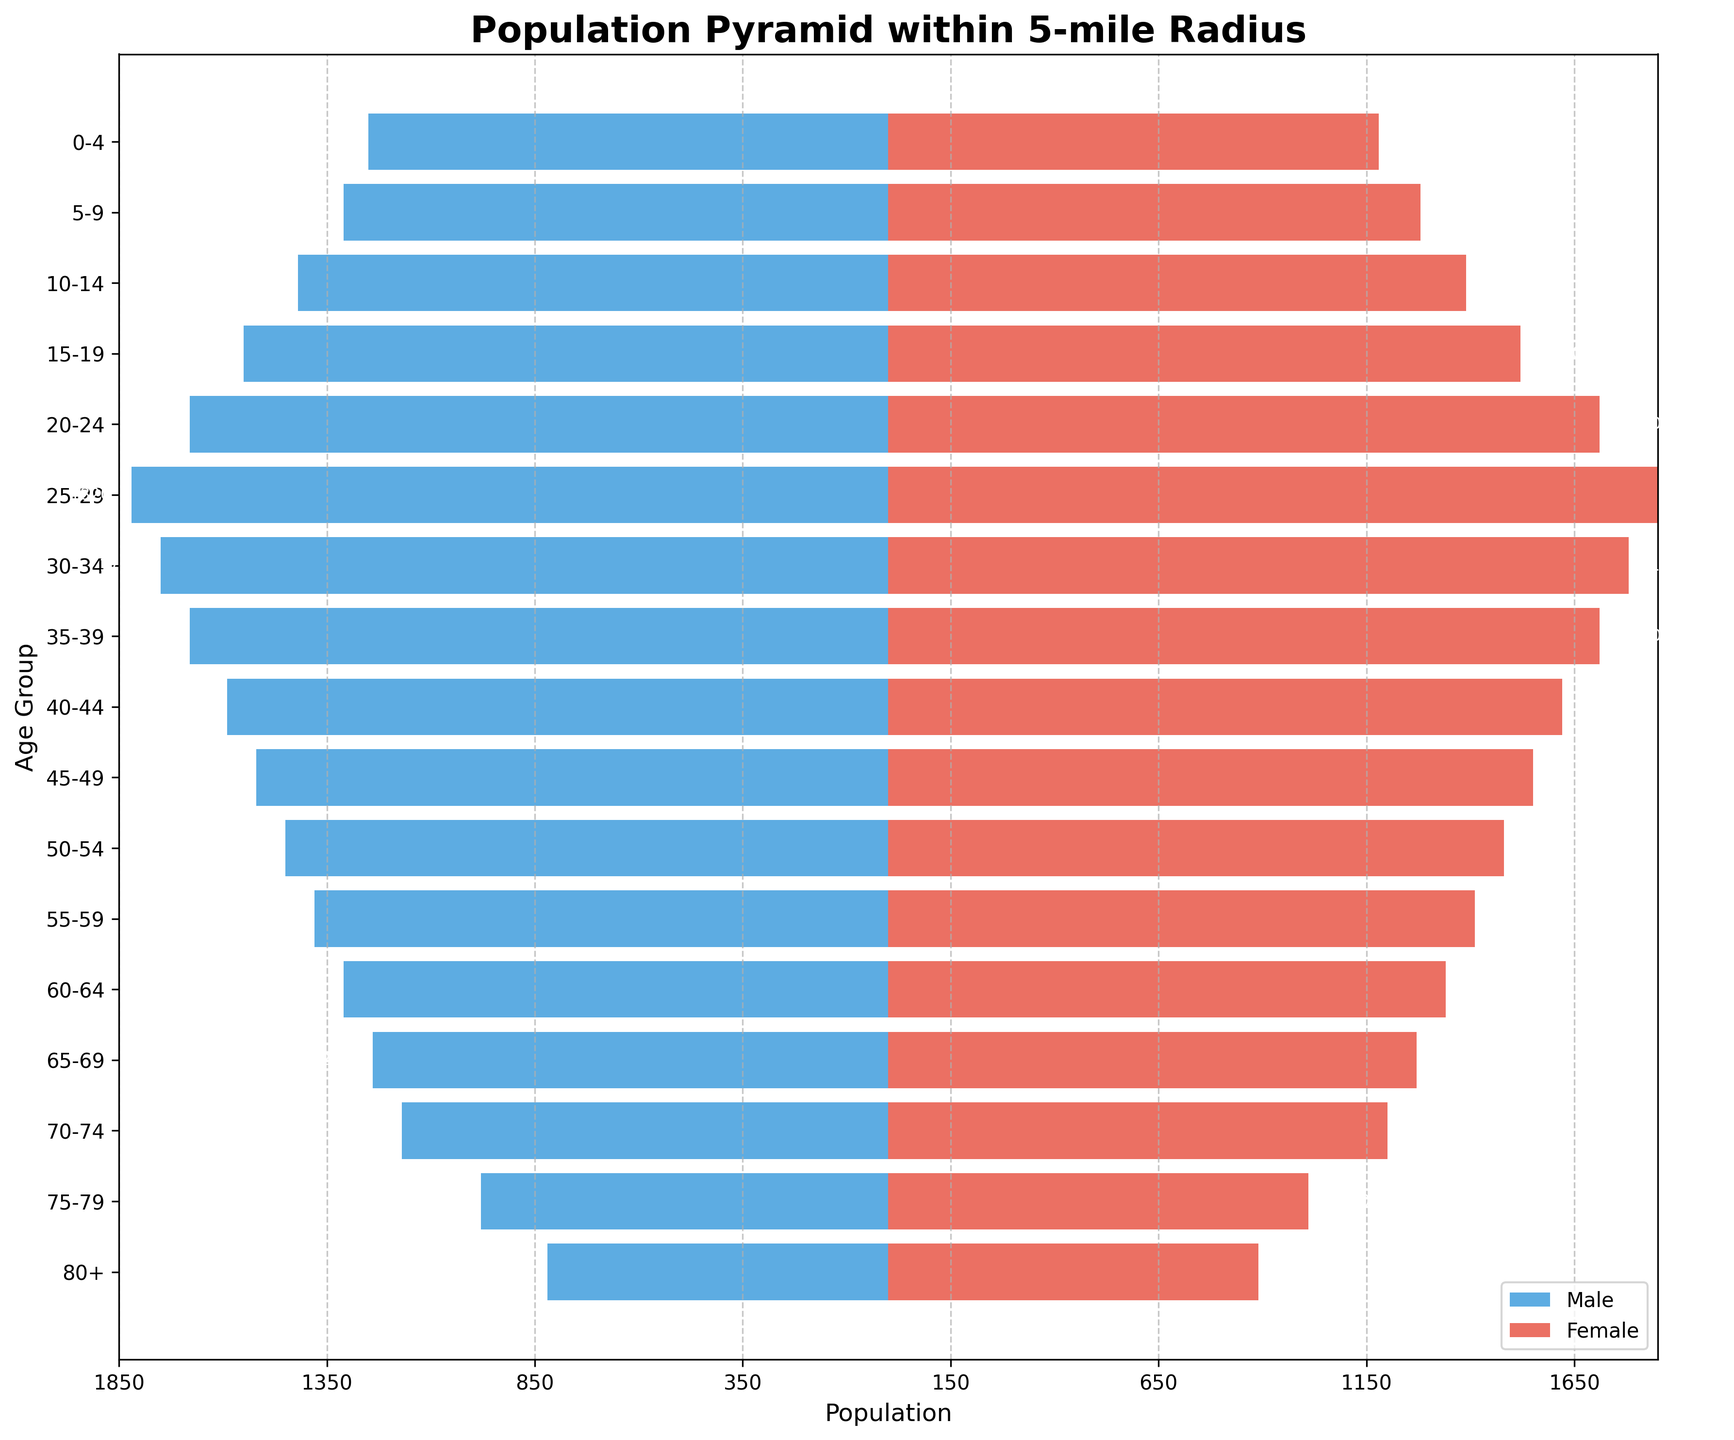What is the title of the plot? The title is typically placed at the top center of the plot in larger, bolder font. By looking at the plot, we can read the title directly.
Answer: Population Pyramid within 5-mile Radius Which age group has the smallest male population? To determine this, we look at the left side of the population pyramid where the male bars are drawn. The age group with the shortest bar represents the smallest population.
Answer: 80+ How many age groups in the plot have a female population greater than 1500? By scanning the right side of the population pyramid where the female bars are located, count the number of bars extending beyond the 1500 mark on the x-axis.
Answer: 5 What is the population difference between males and females in the 25-29 age group? Find the bars corresponding to the 25-29 age group. The male population is represented by the length of the left bar, and the female population is represented by the length of the right bar. Subtract the male population from the female population.
Answer: 30 Which age group has the largest gender imbalance? This requires identifying the age group with the greatest difference between the lengths of the male and female bars. For each age group, calculate the absolute difference between the male and female populations.
Answer: 0-4 What is the total population of the 40-44 age group? Add the male and female populations for the 40-44 age group. The male population is the length of the left bar (negative value but taken in absolute terms), and the female population is the length of the right bar.
Answer: 3210 Compare the male population of the 10-14 age group to the female population of the 15-19 age group. Which is larger? Locate the bars for males in the 10-14 age group and females in the 15-19 age group. Compare the length of these bars to see which one is longer.
Answer: Female population of 15-19 How does the population distribution change as age increases from 0-4 to 80+? Observe the trends for both male and female populations across all age groups from 0-4 to 80+. Generally, note whether the bars increase or decrease in length as the age groups increase.
Answer: Both populations decrease What is the combined population of males and females in the 60-64 and 65-69 age groups? Find the male and female populations for both age groups and sum them up. This involves adding up the male and female populations for 60-64 and 65-69 age groups separately, then adding the totals together.
Answer: 5160 